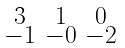Convert formula to latex. <formula><loc_0><loc_0><loc_500><loc_500>\begin{smallmatrix} 3 & 1 & 0 \\ - 1 & - 0 & - 2 \end{smallmatrix}</formula> 